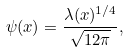<formula> <loc_0><loc_0><loc_500><loc_500>\psi ( x ) = \frac { \lambda ( x ) ^ { 1 / 4 } } { \sqrt { 1 2 \pi } } ,</formula> 